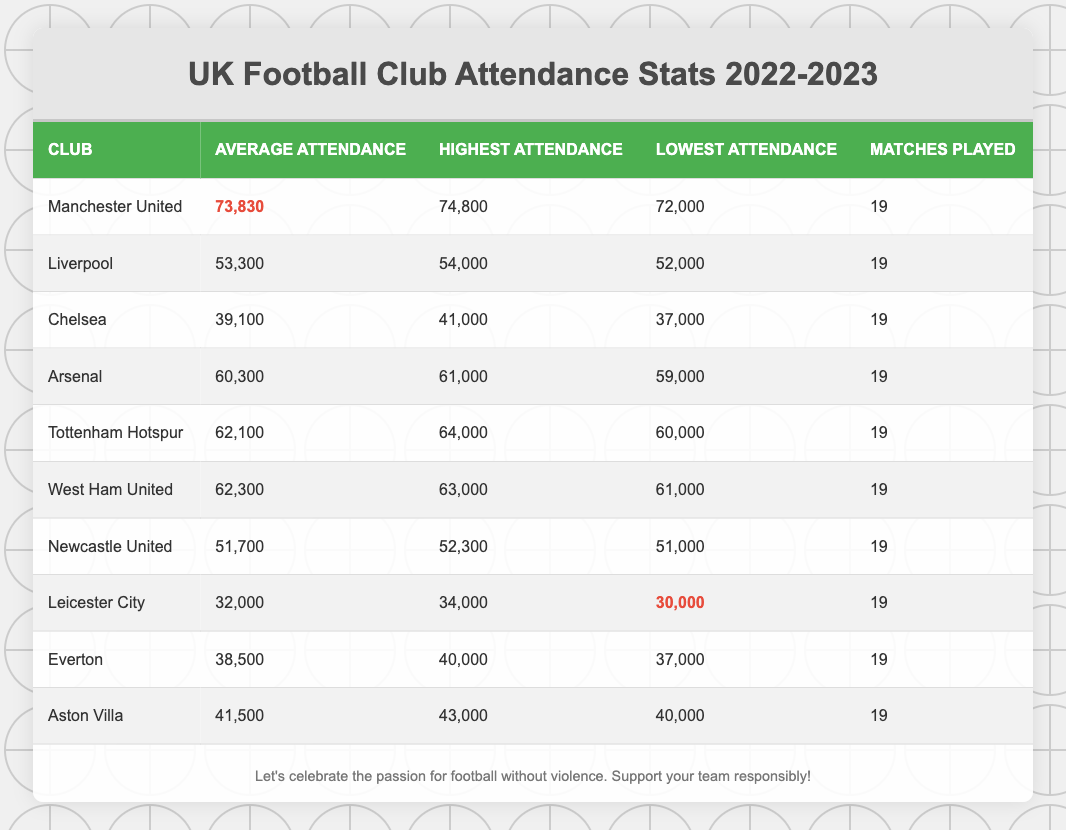What is the average attendance for Manchester United in the 2022-2023 season? The average attendance is listed directly in the table under "Average Attendance" for Manchester United, which shows a value of 73,830.
Answer: 73,830 Which club had the highest average attendance during the 2022-2023 season? By comparing the average attendance values, Manchester United has the highest average attendance at 73,830.
Answer: Manchester United How many matches did Arsenal play in the 2022-2023 season? The number of matches played is shown in the last column for Arsenal, which indicates that they played 19 matches.
Answer: 19 What is the difference between the highest and lowest attendance for Chelsea? The highest attendance for Chelsea is 41,000 and the lowest is 37,000. The difference is calculated as 41,000 - 37,000 = 4,000.
Answer: 4,000 Is the average attendance for Leicester City greater than 30,000? The average attendance for Leicester City is 32,000, which is greater than 30,000.
Answer: Yes What is the total attendance for all matches played by Tottenham Hotspur? To find the total attendance for Tottenham Hotspur, multiply the average attendance (62,100) by the number of matches played (19), resulting in 62,100 * 19 = 1,179,900.
Answer: 1,179,900 Which club had the lowest match attendance and what was it? By reviewing each club's lowest attendance, Leicester City had the lowest at 30,000.
Answer: Leicester City, 30,000 If we sum the average attendances of Liverpool and Newcastle United, what would the total be? The average attendance for Liverpool is 53,300 and for Newcastle United is 51,700. Adding them gives 53,300 + 51,700 = 105,000.
Answer: 105,000 Which club has the closest average attendance to Aston Villa? Aston Villa has an average attendance of 41,500. Comparing others, Everton closely follows with 38,500, a difference of 3,000.
Answer: Everton How many clubs had an average attendance over 60,000 in the 2022-2023 season? Checking the average attendance data, the clubs over 60,000 are Manchester United, Arsenal, Tottenham Hotspur, and West Ham United, totaling 4 clubs.
Answer: 4 